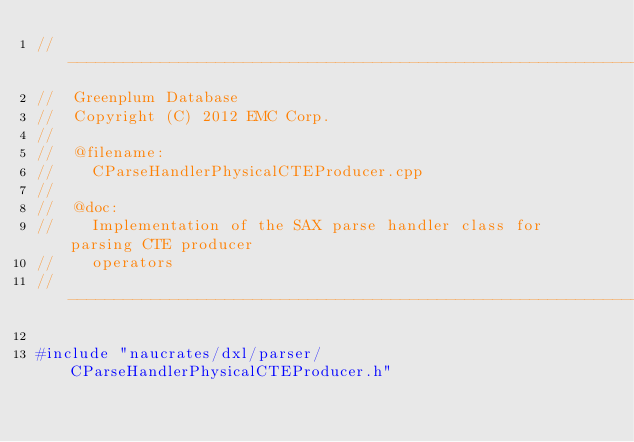<code> <loc_0><loc_0><loc_500><loc_500><_C++_>//---------------------------------------------------------------------------
//	Greenplum Database
//	Copyright (C) 2012 EMC Corp.
//
//	@filename:
//		CParseHandlerPhysicalCTEProducer.cpp
//
//	@doc:
//		Implementation of the SAX parse handler class for parsing CTE producer
//		operators
//---------------------------------------------------------------------------

#include "naucrates/dxl/parser/CParseHandlerPhysicalCTEProducer.h"
</code> 